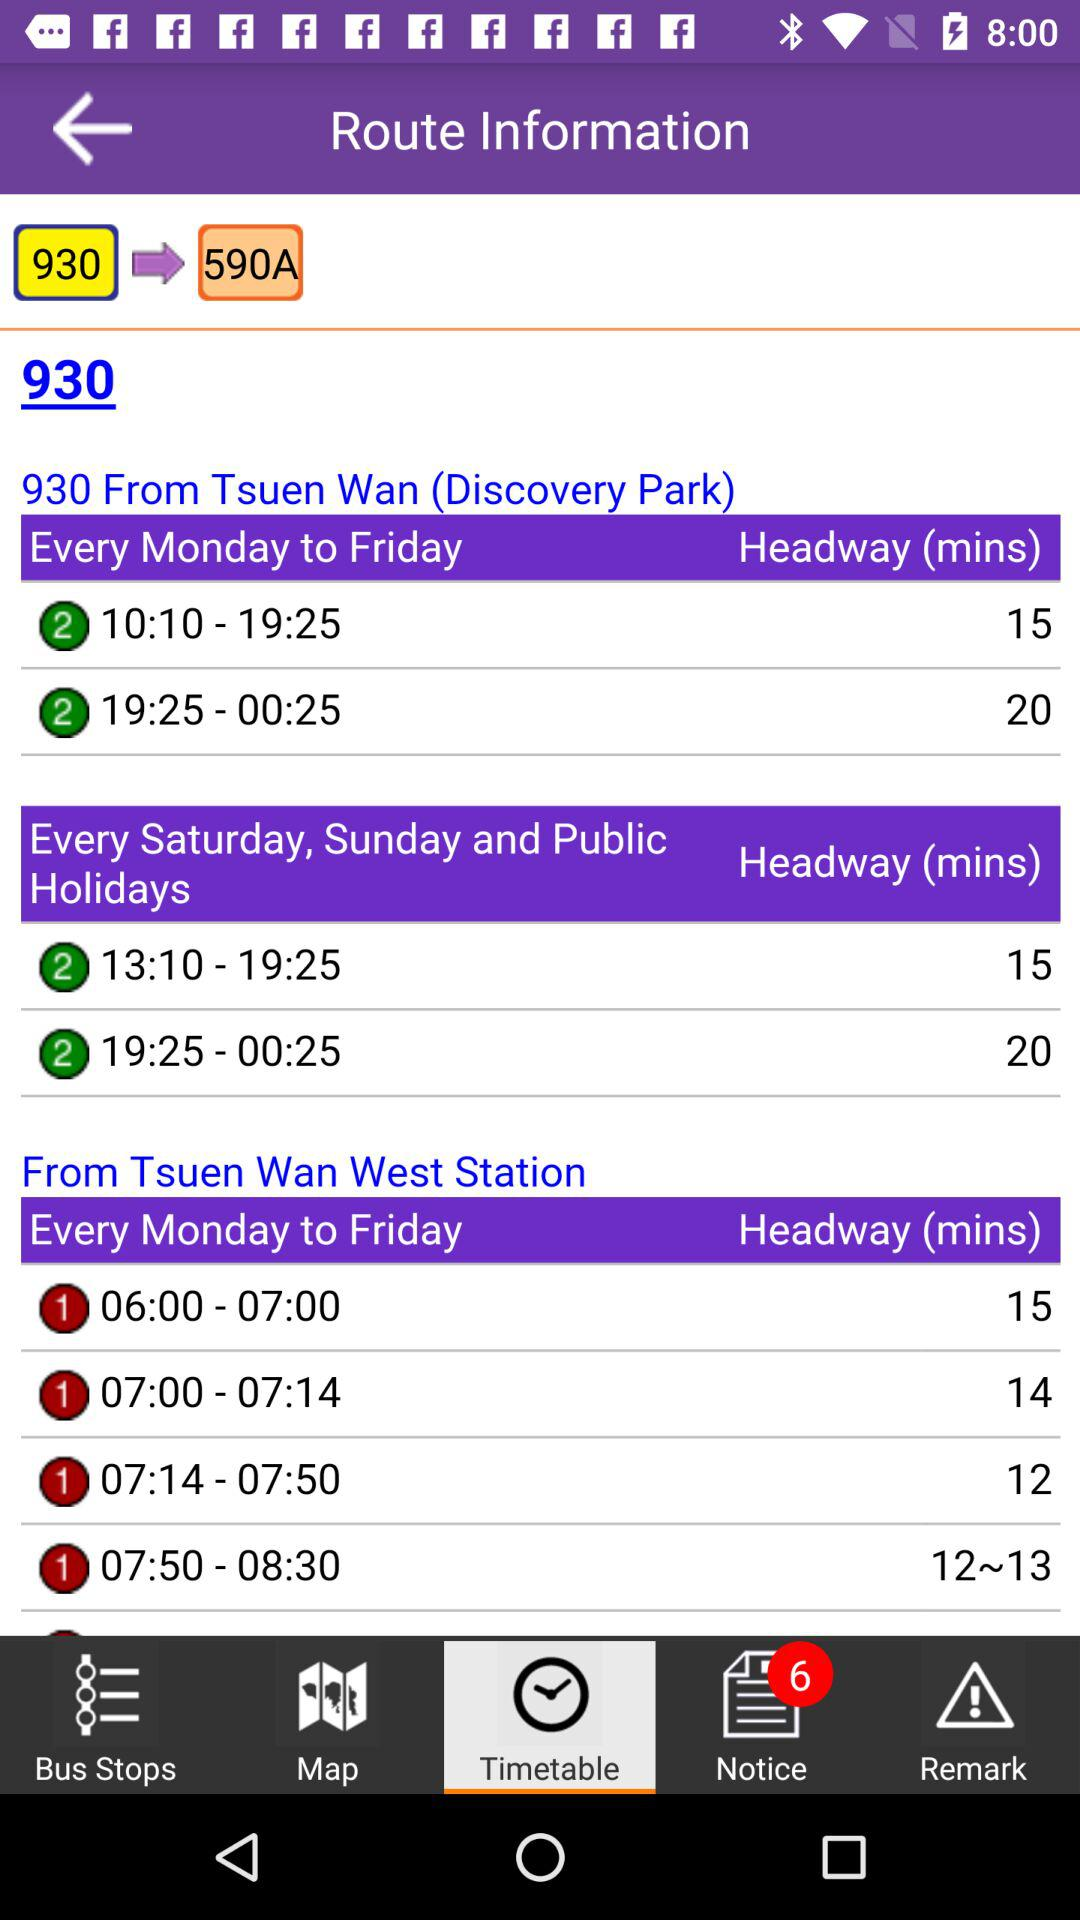Which option is selected? The selected option is "Timetable". 